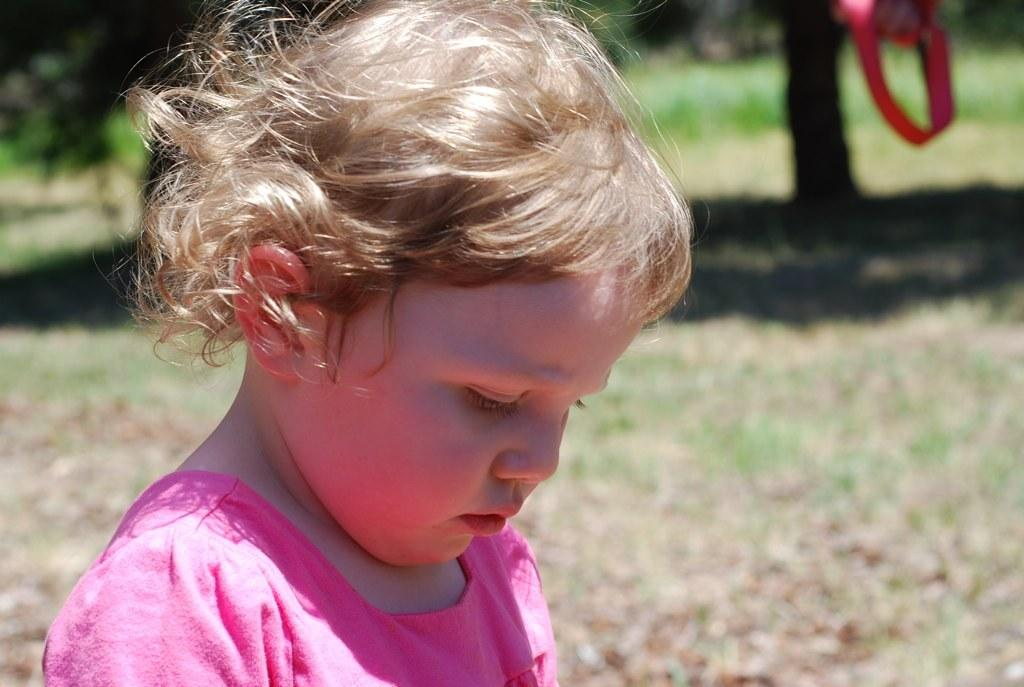What is the main subject of the image? There is a child in the image. What is the child doing in the image? The child is looking downwards. What type of environment is visible in the image? There is grass visible in the image. Can you describe the position of the person in the image? The person is bending downwards. What type of toothpaste is the rabbit using in the image? There is no toothpaste or rabbit present in the image. How many nails can be seen in the image? There are no nails visible in the image. 